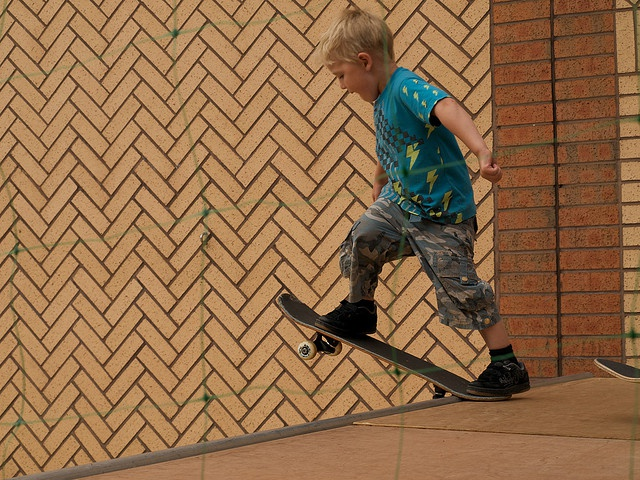Describe the objects in this image and their specific colors. I can see people in tan, black, and maroon tones, skateboard in tan, black, and maroon tones, and skateboard in tan, black, maroon, and gray tones in this image. 